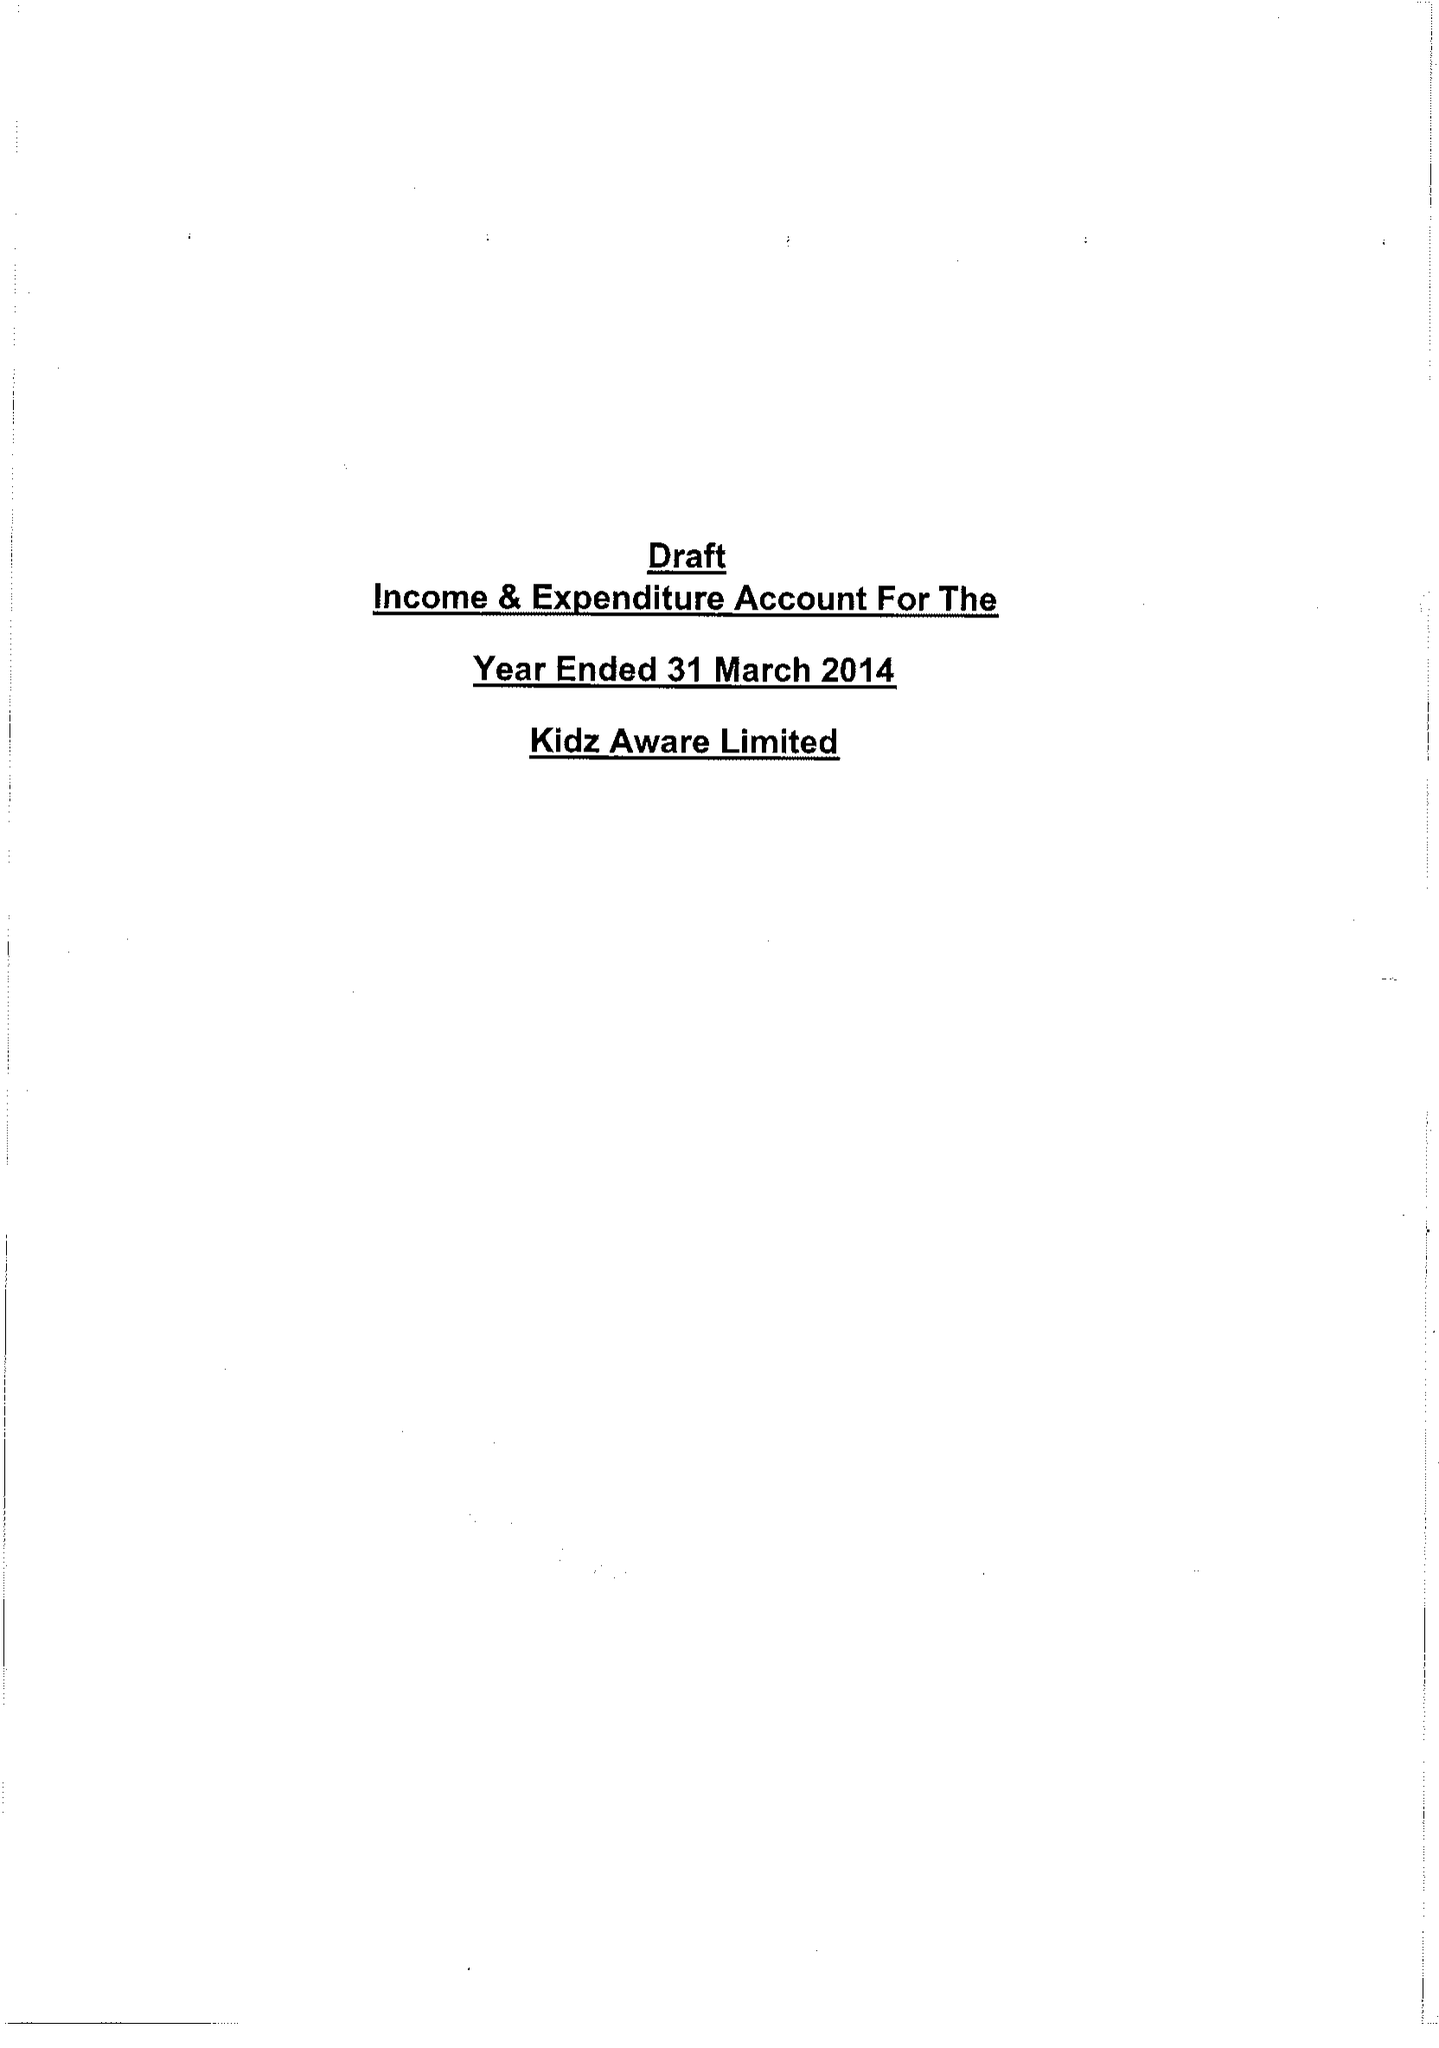What is the value for the spending_annually_in_british_pounds?
Answer the question using a single word or phrase. 32360.00 